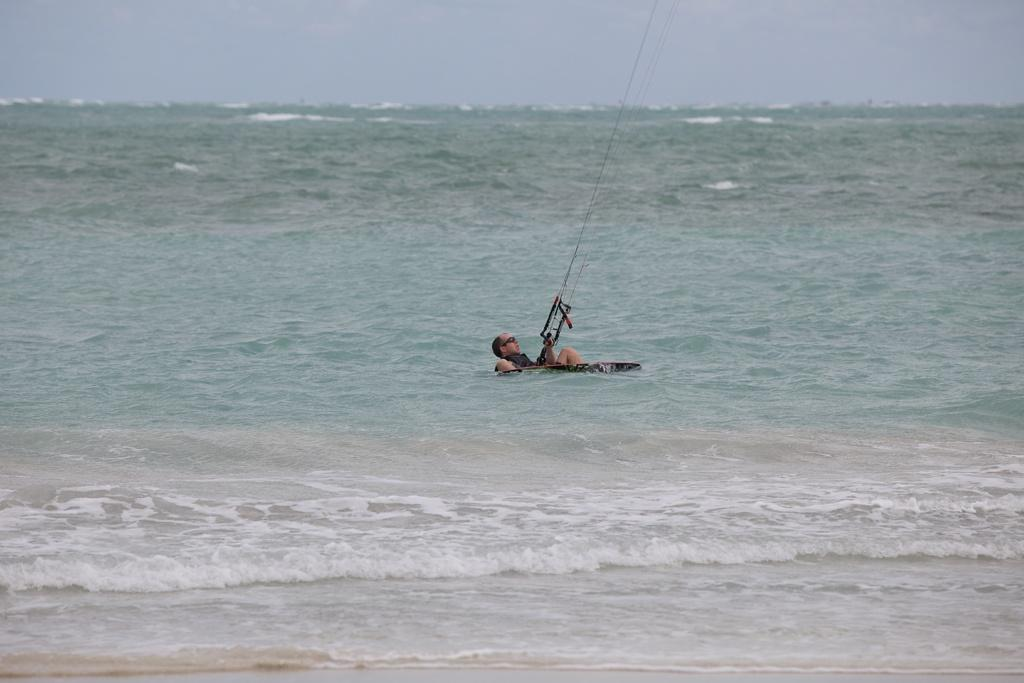What is the main subject in the foreground of the image? There is a man in the foreground of the image. What is the man doing in the image? The man is surfing on the water. What is the man holding while surfing? The man is holding a rope. What can be seen at the top of the image? The sky is visible at the top of the image. How many feet are visible in the image? There is no mention of feet in the image, as the focus is on the man surfing and holding a rope. 